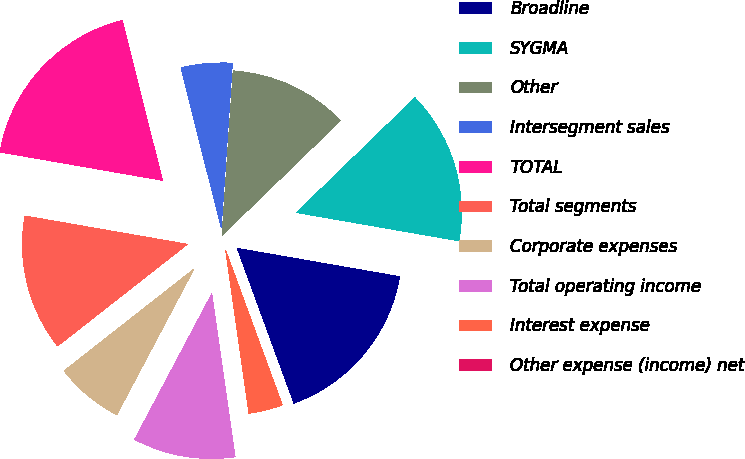Convert chart. <chart><loc_0><loc_0><loc_500><loc_500><pie_chart><fcel>Broadline<fcel>SYGMA<fcel>Other<fcel>Intersegment sales<fcel>TOTAL<fcel>Total segments<fcel>Corporate expenses<fcel>Total operating income<fcel>Interest expense<fcel>Other expense (income) net<nl><fcel>16.67%<fcel>15.0%<fcel>11.67%<fcel>5.0%<fcel>18.33%<fcel>13.33%<fcel>6.67%<fcel>10.0%<fcel>3.33%<fcel>0.0%<nl></chart> 